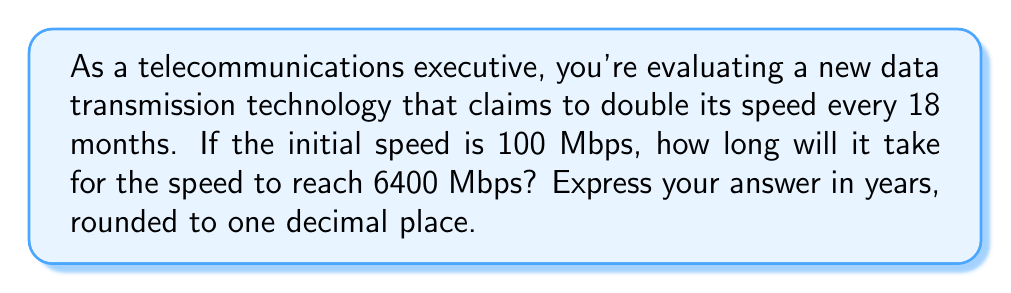What is the answer to this math problem? Let's approach this step-by-step using logarithmic functions:

1) Let $t$ be the time in years and $S(t)$ be the speed in Mbps after $t$ years.

2) The speed doubles every 18 months (1.5 years). We can express this as:

   $S(t) = 100 \cdot 2^{\frac{t}{1.5}}$

3) We want to find $t$ when $S(t) = 6400$. So we can set up the equation:

   $6400 = 100 \cdot 2^{\frac{t}{1.5}}$

4) Divide both sides by 100:

   $64 = 2^{\frac{t}{1.5}}$

5) Take the logarithm (base 2) of both sides:

   $\log_2(64) = \frac{t}{1.5}$

6) Simplify the left side:

   $6 = \frac{t}{1.5}$

7) Multiply both sides by 1.5:

   $9 = t$

Therefore, it will take 9 years for the speed to reach 6400 Mbps.
Answer: 9.0 years 